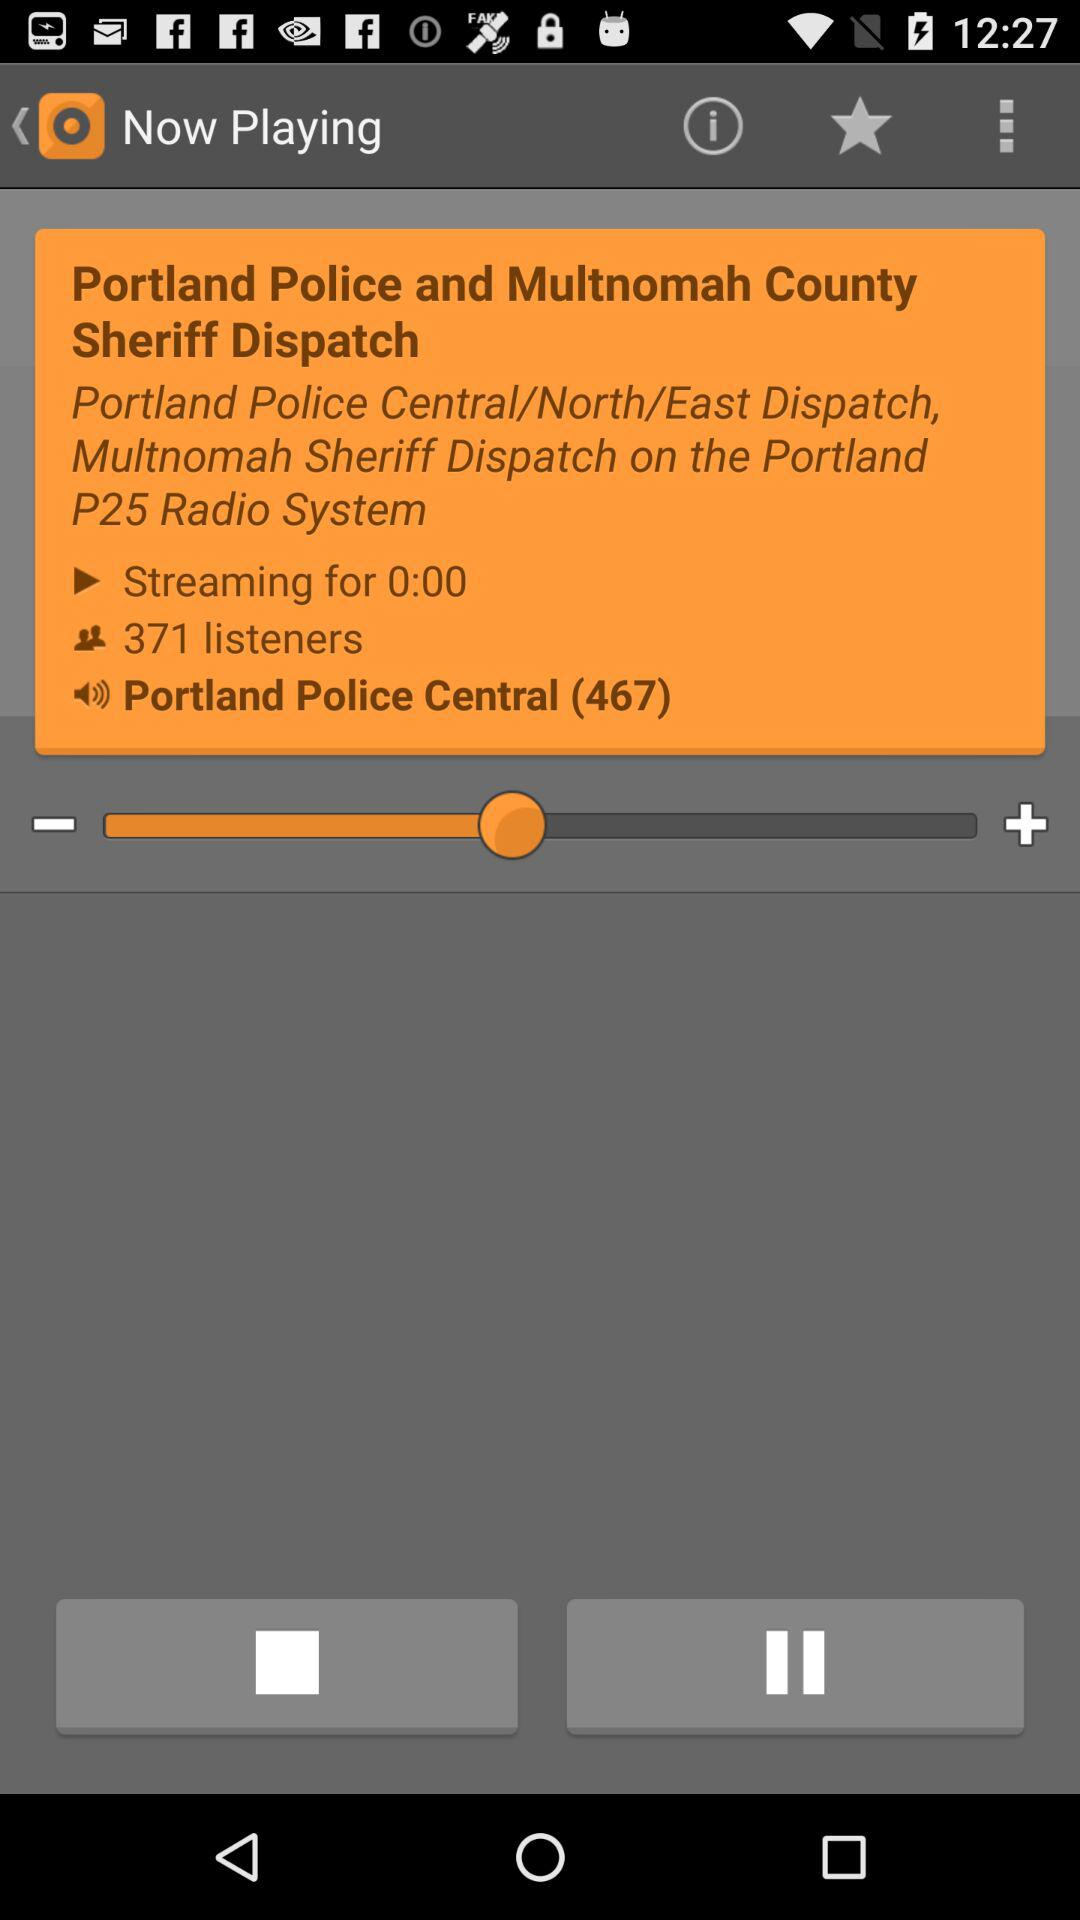Which audio is playing? The audio is "Portland Police Central (467)". 